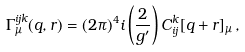<formula> <loc_0><loc_0><loc_500><loc_500>\Gamma ^ { i j k } _ { \mu } ( q , r ) = ( 2 \pi ) ^ { 4 } i \left ( \frac { 2 } { g ^ { \prime } } \right ) C ^ { k } _ { i j } [ q + r ] _ { \mu } \, ,</formula> 